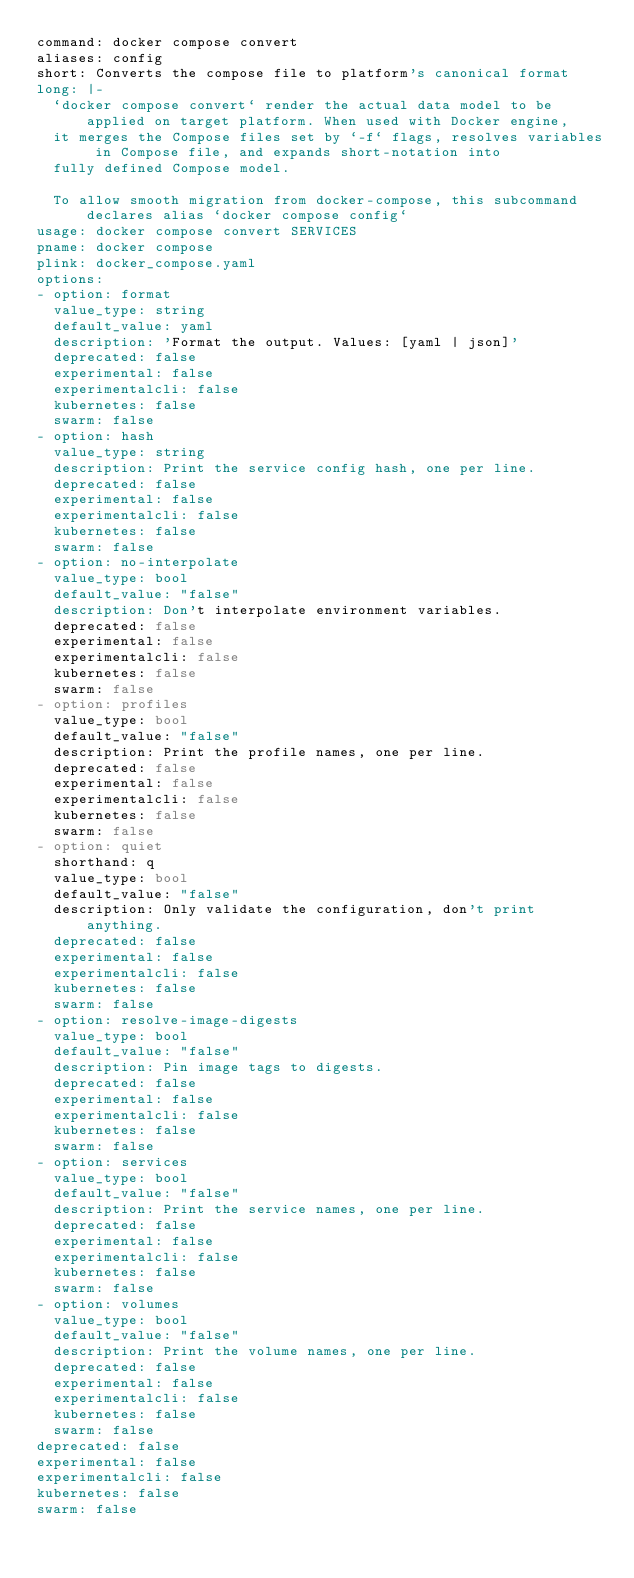<code> <loc_0><loc_0><loc_500><loc_500><_YAML_>command: docker compose convert
aliases: config
short: Converts the compose file to platform's canonical format
long: |-
  `docker compose convert` render the actual data model to be applied on target platform. When used with Docker engine,
  it merges the Compose files set by `-f` flags, resolves variables in Compose file, and expands short-notation into
  fully defined Compose model.

  To allow smooth migration from docker-compose, this subcommand declares alias `docker compose config`
usage: docker compose convert SERVICES
pname: docker compose
plink: docker_compose.yaml
options:
- option: format
  value_type: string
  default_value: yaml
  description: 'Format the output. Values: [yaml | json]'
  deprecated: false
  experimental: false
  experimentalcli: false
  kubernetes: false
  swarm: false
- option: hash
  value_type: string
  description: Print the service config hash, one per line.
  deprecated: false
  experimental: false
  experimentalcli: false
  kubernetes: false
  swarm: false
- option: no-interpolate
  value_type: bool
  default_value: "false"
  description: Don't interpolate environment variables.
  deprecated: false
  experimental: false
  experimentalcli: false
  kubernetes: false
  swarm: false
- option: profiles
  value_type: bool
  default_value: "false"
  description: Print the profile names, one per line.
  deprecated: false
  experimental: false
  experimentalcli: false
  kubernetes: false
  swarm: false
- option: quiet
  shorthand: q
  value_type: bool
  default_value: "false"
  description: Only validate the configuration, don't print anything.
  deprecated: false
  experimental: false
  experimentalcli: false
  kubernetes: false
  swarm: false
- option: resolve-image-digests
  value_type: bool
  default_value: "false"
  description: Pin image tags to digests.
  deprecated: false
  experimental: false
  experimentalcli: false
  kubernetes: false
  swarm: false
- option: services
  value_type: bool
  default_value: "false"
  description: Print the service names, one per line.
  deprecated: false
  experimental: false
  experimentalcli: false
  kubernetes: false
  swarm: false
- option: volumes
  value_type: bool
  default_value: "false"
  description: Print the volume names, one per line.
  deprecated: false
  experimental: false
  experimentalcli: false
  kubernetes: false
  swarm: false
deprecated: false
experimental: false
experimentalcli: false
kubernetes: false
swarm: false

</code> 